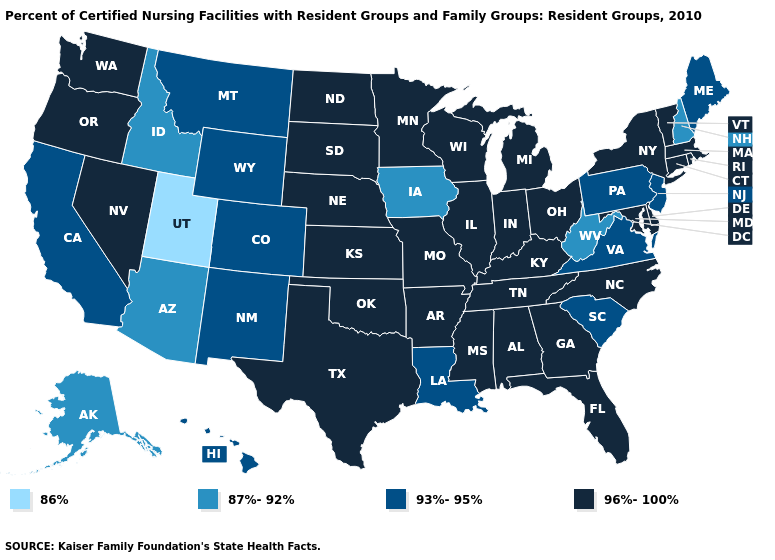Name the states that have a value in the range 93%-95%?
Be succinct. California, Colorado, Hawaii, Louisiana, Maine, Montana, New Jersey, New Mexico, Pennsylvania, South Carolina, Virginia, Wyoming. Which states have the highest value in the USA?
Quick response, please. Alabama, Arkansas, Connecticut, Delaware, Florida, Georgia, Illinois, Indiana, Kansas, Kentucky, Maryland, Massachusetts, Michigan, Minnesota, Mississippi, Missouri, Nebraska, Nevada, New York, North Carolina, North Dakota, Ohio, Oklahoma, Oregon, Rhode Island, South Dakota, Tennessee, Texas, Vermont, Washington, Wisconsin. What is the lowest value in the USA?
Be succinct. 86%. Which states have the lowest value in the USA?
Give a very brief answer. Utah. Name the states that have a value in the range 86%?
Quick response, please. Utah. How many symbols are there in the legend?
Quick response, please. 4. What is the highest value in the USA?
Keep it brief. 96%-100%. Does Mississippi have a lower value than Georgia?
Be succinct. No. Name the states that have a value in the range 93%-95%?
Concise answer only. California, Colorado, Hawaii, Louisiana, Maine, Montana, New Jersey, New Mexico, Pennsylvania, South Carolina, Virginia, Wyoming. Does New Hampshire have the highest value in the USA?
Write a very short answer. No. How many symbols are there in the legend?
Be succinct. 4. Does Mississippi have a lower value than Kansas?
Quick response, please. No. Among the states that border Nebraska , does Kansas have the lowest value?
Short answer required. No. Does Idaho have the highest value in the USA?
Give a very brief answer. No. Name the states that have a value in the range 96%-100%?
Write a very short answer. Alabama, Arkansas, Connecticut, Delaware, Florida, Georgia, Illinois, Indiana, Kansas, Kentucky, Maryland, Massachusetts, Michigan, Minnesota, Mississippi, Missouri, Nebraska, Nevada, New York, North Carolina, North Dakota, Ohio, Oklahoma, Oregon, Rhode Island, South Dakota, Tennessee, Texas, Vermont, Washington, Wisconsin. 